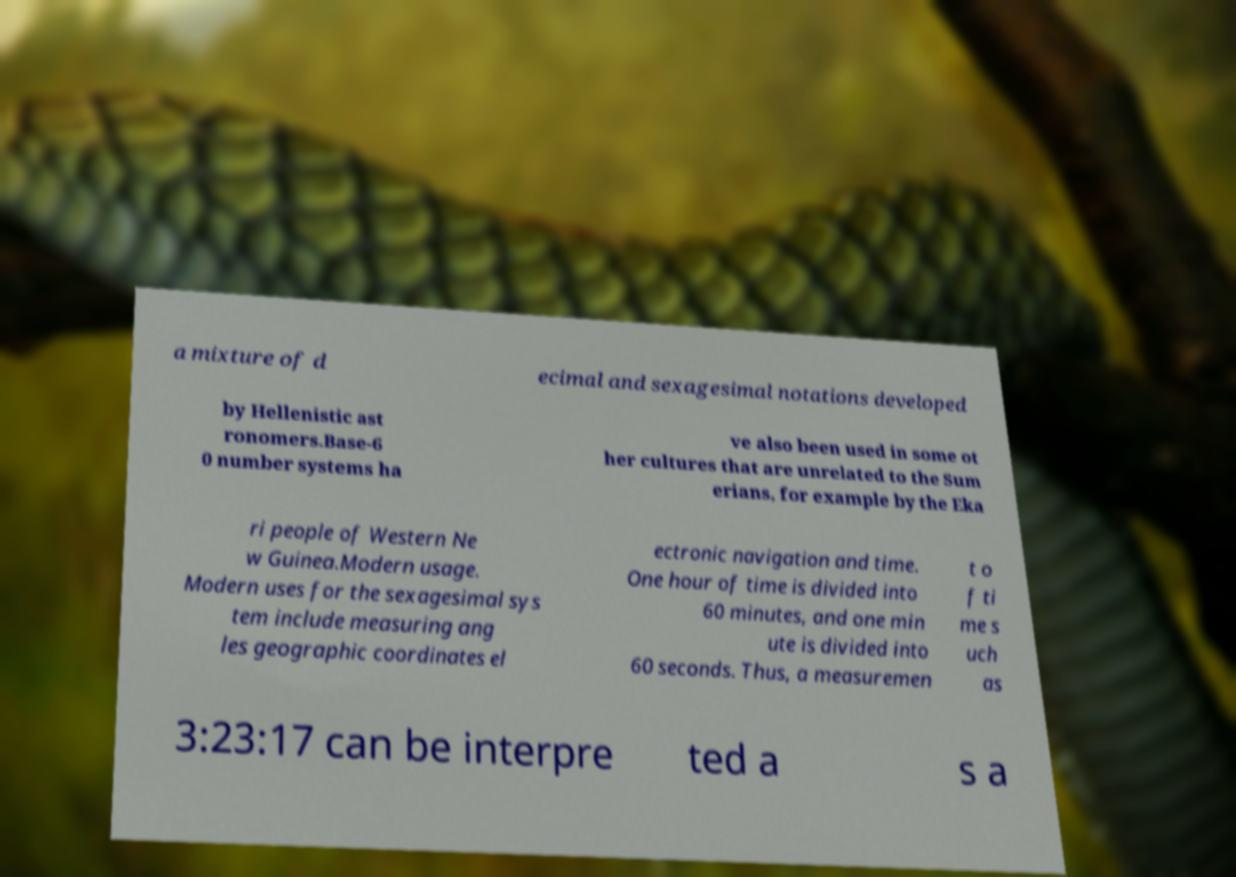For documentation purposes, I need the text within this image transcribed. Could you provide that? a mixture of d ecimal and sexagesimal notations developed by Hellenistic ast ronomers.Base-6 0 number systems ha ve also been used in some ot her cultures that are unrelated to the Sum erians, for example by the Eka ri people of Western Ne w Guinea.Modern usage. Modern uses for the sexagesimal sys tem include measuring ang les geographic coordinates el ectronic navigation and time. One hour of time is divided into 60 minutes, and one min ute is divided into 60 seconds. Thus, a measuremen t o f ti me s uch as 3:23:17 can be interpre ted a s a 